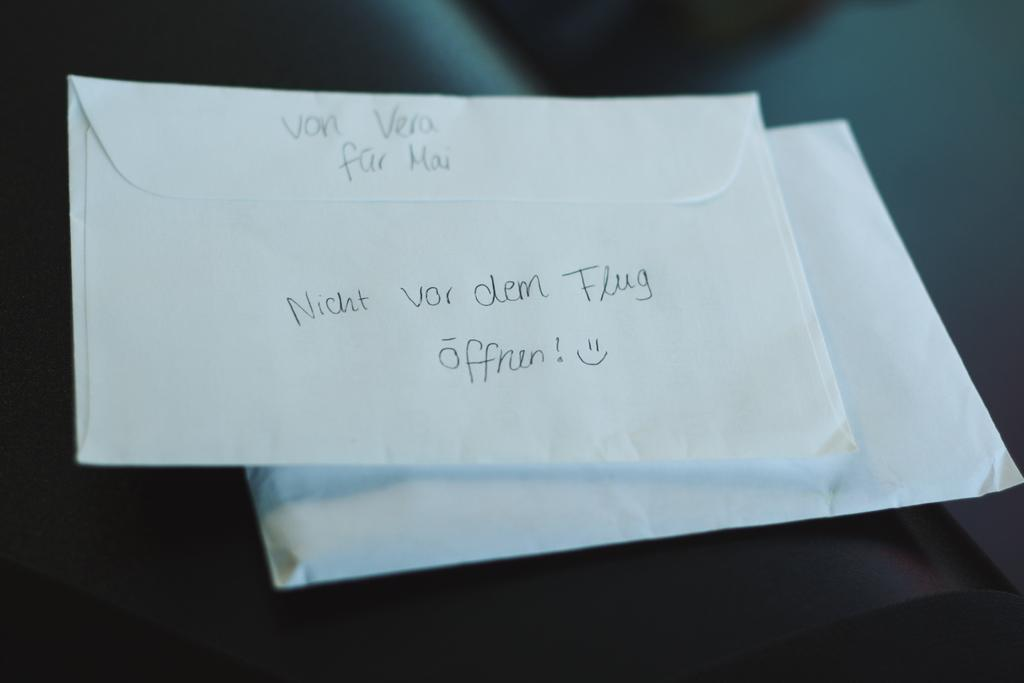<image>
Create a compact narrative representing the image presented. An envelope that says "von vera fur mai" at the top 